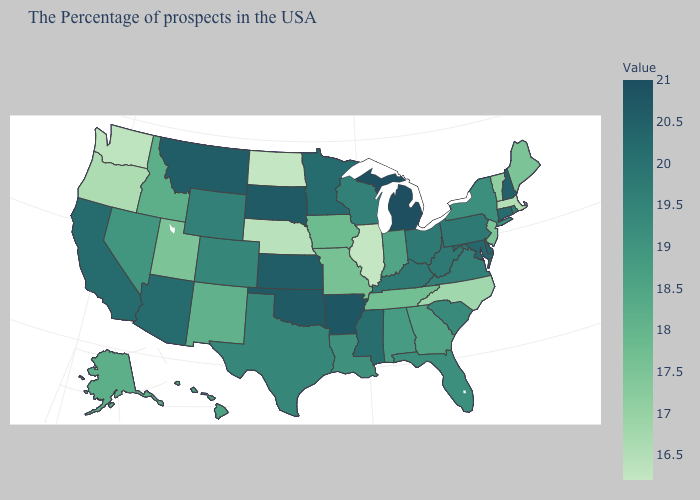Which states have the lowest value in the USA?
Write a very short answer. Illinois, North Dakota. Which states hav the highest value in the West?
Give a very brief answer. Montana. Does Washington have the lowest value in the West?
Write a very short answer. Yes. Which states have the lowest value in the USA?
Short answer required. Illinois, North Dakota. Among the states that border Washington , which have the lowest value?
Short answer required. Oregon. 